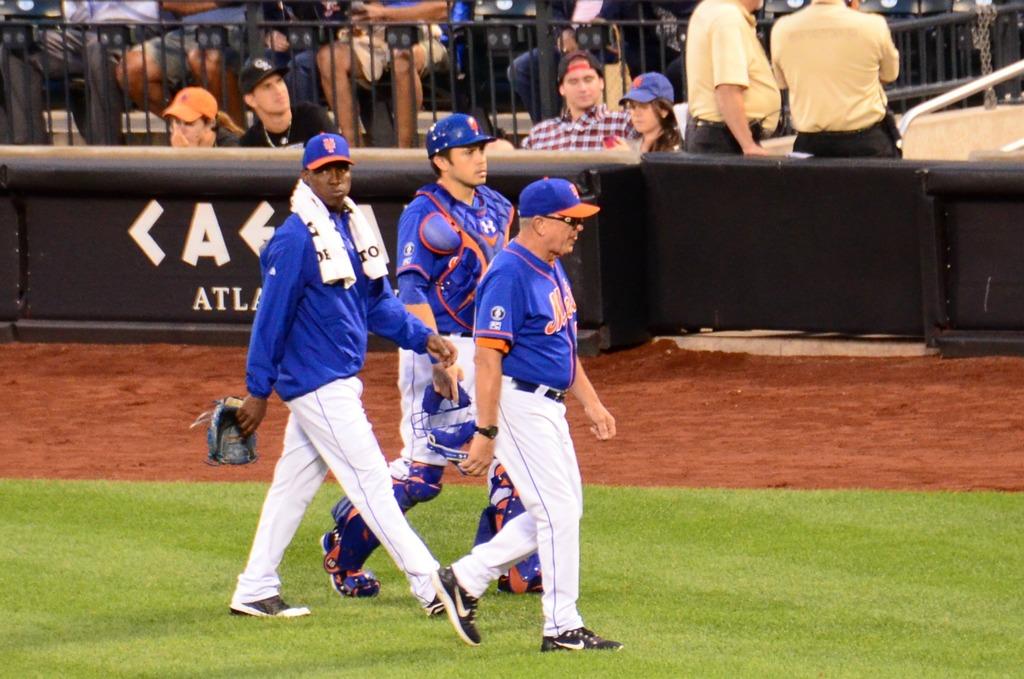What does the teams hat say?
Your answer should be compact. Ny. What team do these people represent?
Keep it short and to the point. Mets. 